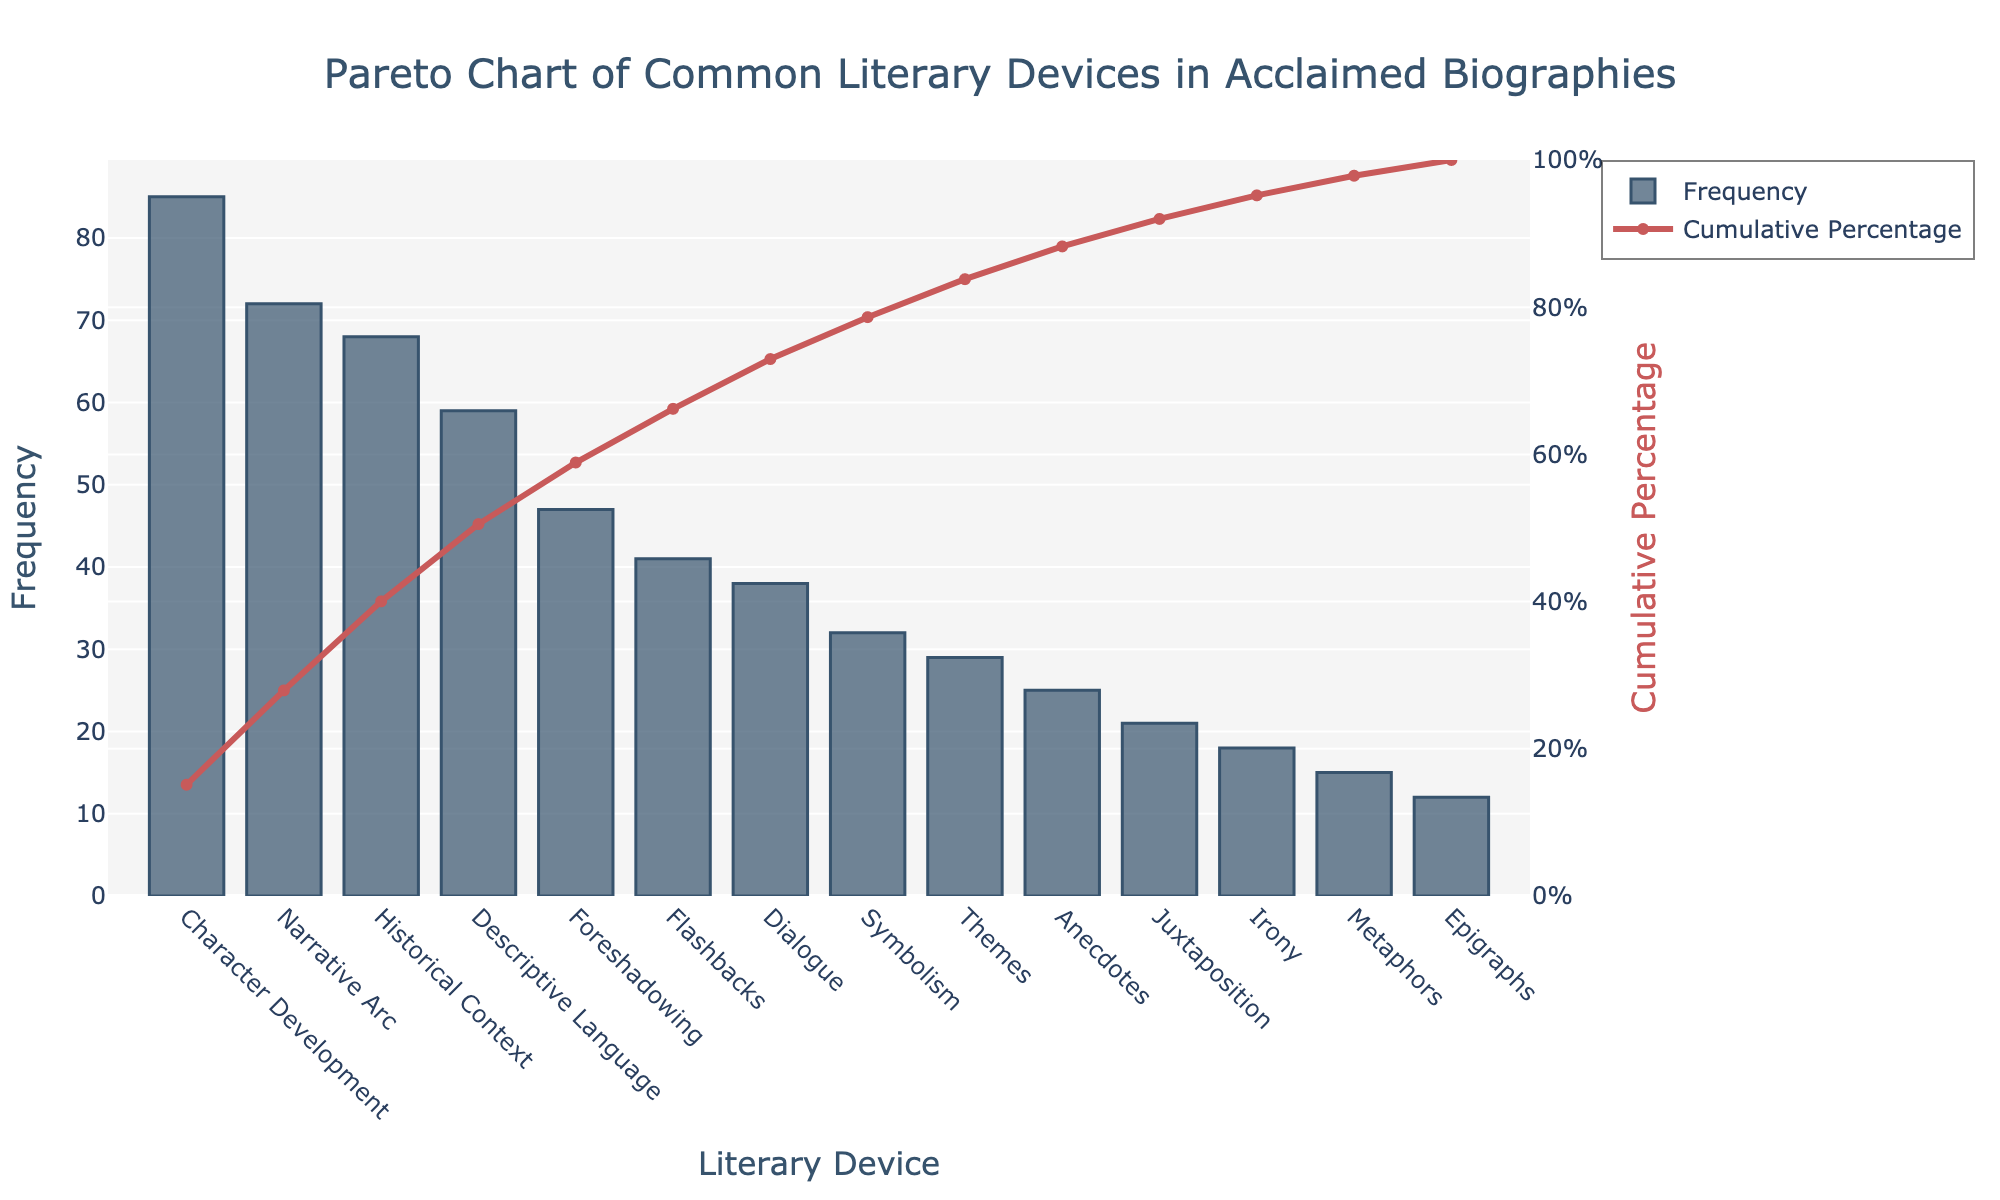What is the title of the figure? The title is written prominently at the top of the figure. It reads "Pareto Chart of Common Literary Devices in Acclaimed Biographies."
Answer: Pareto Chart of Common Literary Devices in Acclaimed Biographies Which literary device has the highest frequency? The highest bar in the bar chart represents the literary device with the highest frequency, which is "Character Development" at 85.
Answer: Character Development What is the cumulative percentage for "Descriptive Language"? Locate "Descriptive Language" on the x-axis and refer to the corresponding point on the line for cumulative percentage, which shows around 66%.
Answer: Approximately 66% How many literary devices have a frequency of 40 or more? Count the bars that have a frequency of 40 or above: Character Development, Narrative Arc, Historical Context, Descriptive Language, Foreshadowing, Flashbacks, and Dialogue.
Answer: 7 What is the difference in frequency between "Historical Context" and "Dialogue"? Subtract the frequency of Dialogue (38) from that of Historical Context (68), which is 68 - 38.
Answer: 30 What cumulative percentage is reached after including "Foreshadowing"? The cumulative percentage after "Foreshadowing" (47) is found on the line chart, which shows around 78%.
Answer: Approximately 78% Which literary device comes after "Metaphors" in the sorted list? Locate "Metaphors" on the x-axis and see the next bar, which is "Epigraphs."
Answer: Epigraphs Which literary device has the lowest frequency? The shortest bar represents the lowest frequency, which is "Epigraphs" at 12.
Answer: Epigraphs What is the total combined frequency for "Anecdotes" and "Juxtaposition"? Add the frequencies of "Anecdotes" (25) and "Juxtaposition" (21), which is 25 + 21.
Answer: 46 What is the frequency range among all the literary devices? Subtract the frequency of the lowest device (Epigraphs, 12) from the highest device (Character Development, 85), which is 85 - 12.
Answer: 73 